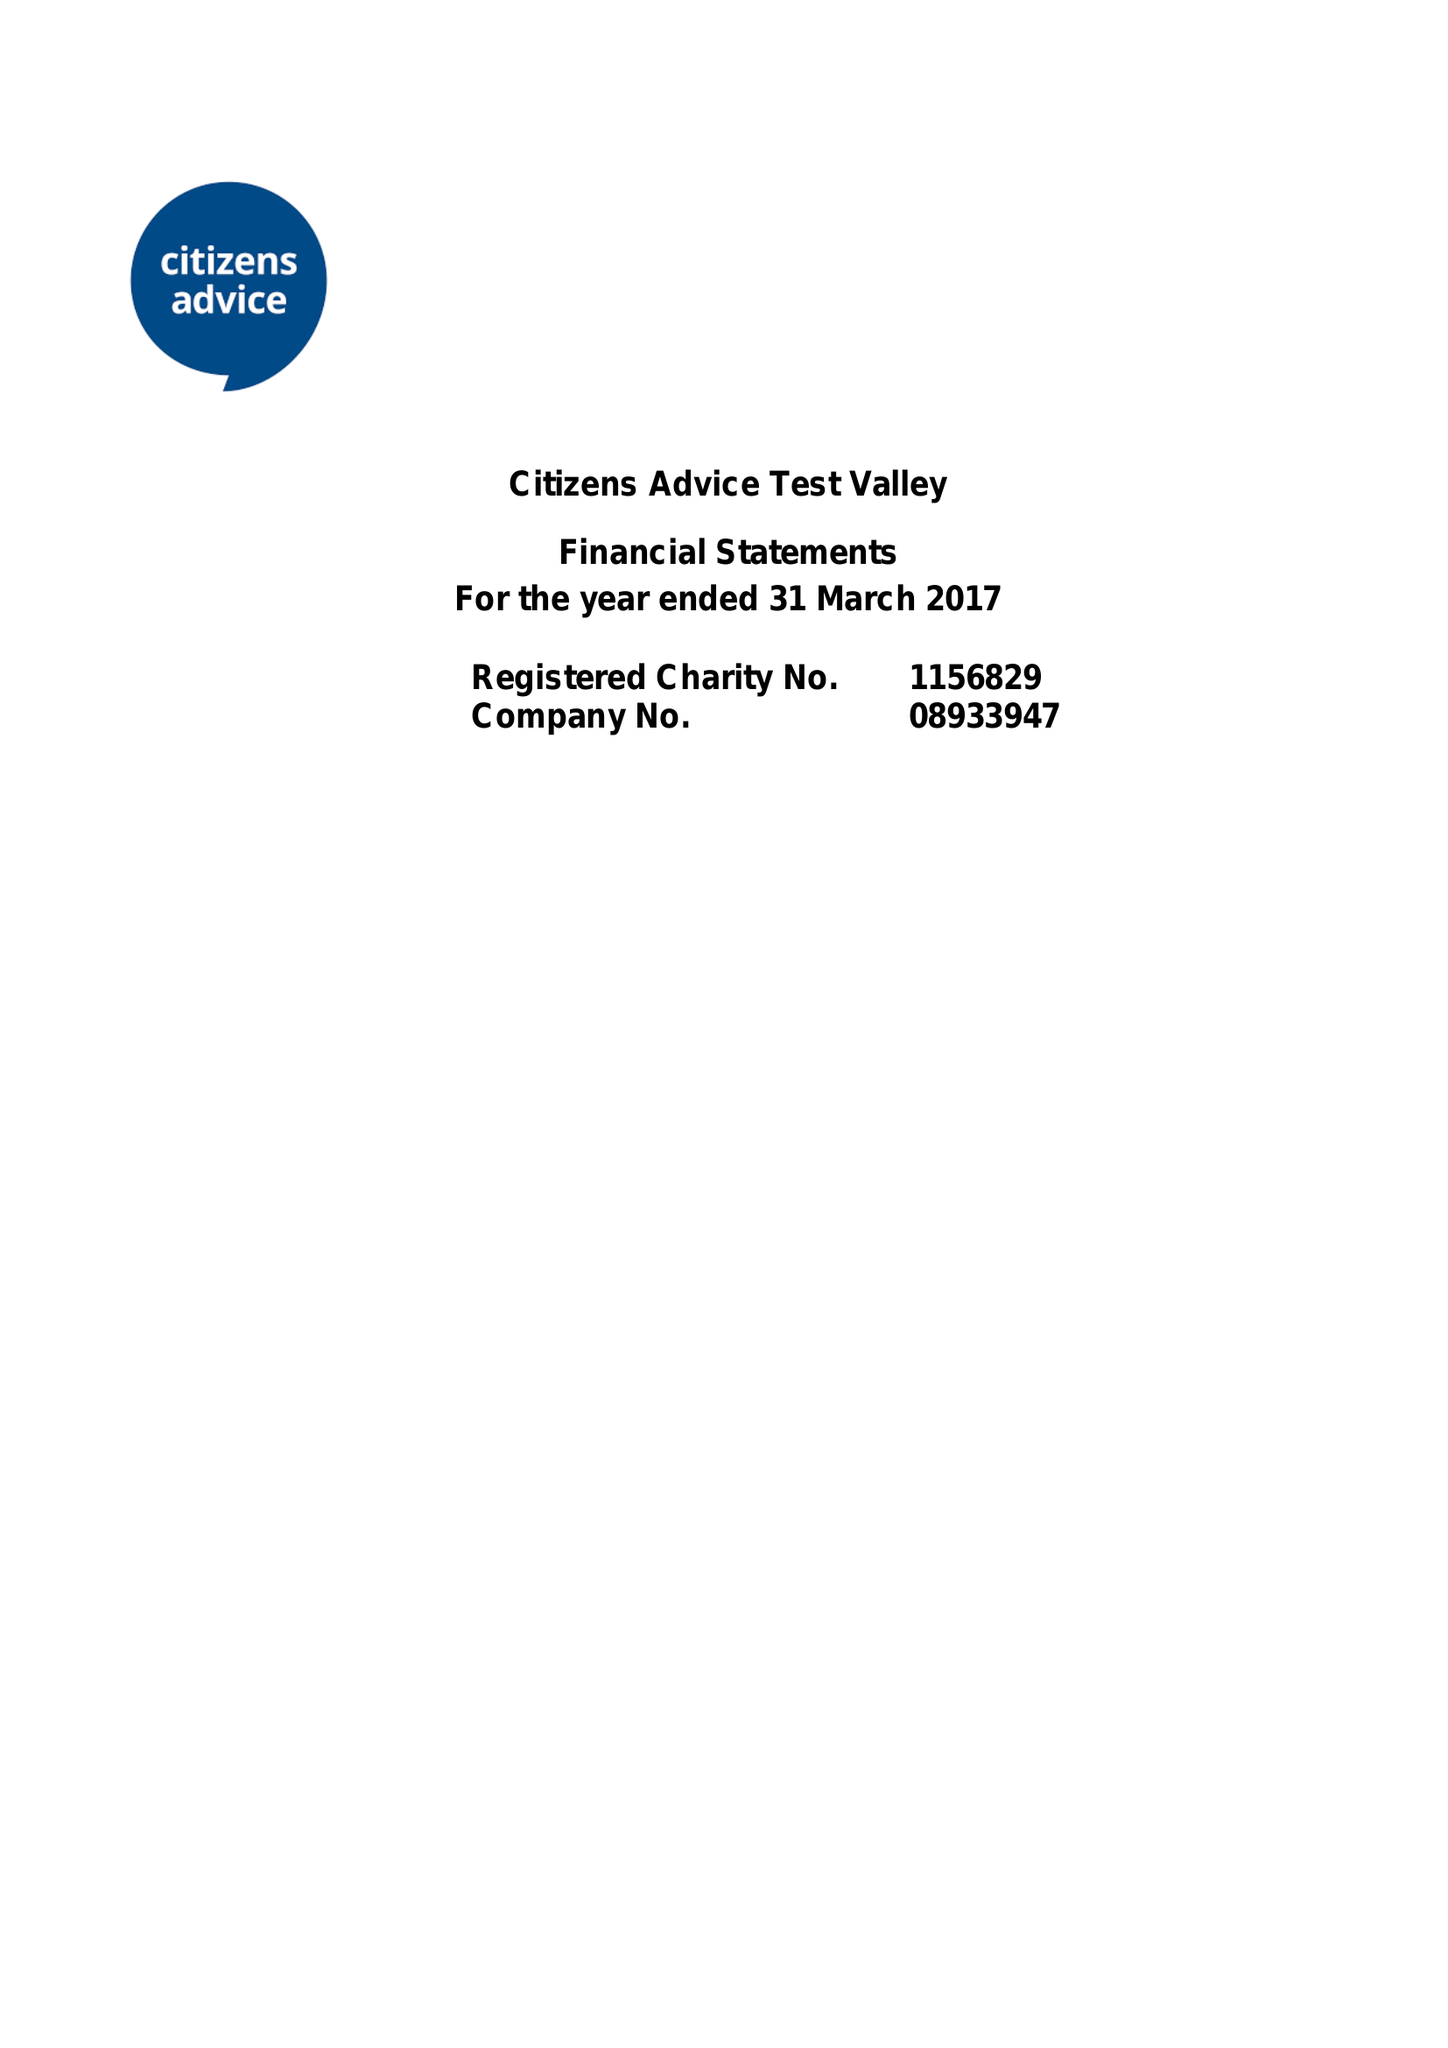What is the value for the address__post_town?
Answer the question using a single word or phrase. ANDOVER 